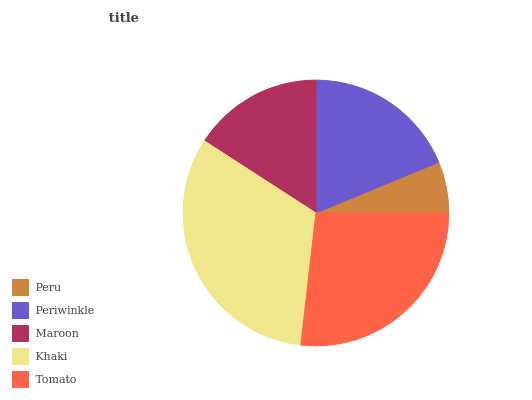Is Peru the minimum?
Answer yes or no. Yes. Is Khaki the maximum?
Answer yes or no. Yes. Is Periwinkle the minimum?
Answer yes or no. No. Is Periwinkle the maximum?
Answer yes or no. No. Is Periwinkle greater than Peru?
Answer yes or no. Yes. Is Peru less than Periwinkle?
Answer yes or no. Yes. Is Peru greater than Periwinkle?
Answer yes or no. No. Is Periwinkle less than Peru?
Answer yes or no. No. Is Periwinkle the high median?
Answer yes or no. Yes. Is Periwinkle the low median?
Answer yes or no. Yes. Is Peru the high median?
Answer yes or no. No. Is Maroon the low median?
Answer yes or no. No. 